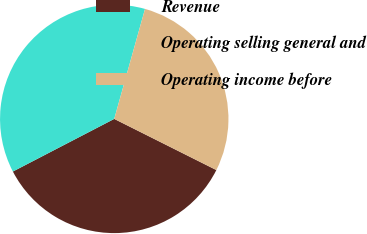Convert chart. <chart><loc_0><loc_0><loc_500><loc_500><pie_chart><fcel>Revenue<fcel>Operating selling general and<fcel>Operating income before<nl><fcel>34.99%<fcel>36.97%<fcel>28.05%<nl></chart> 